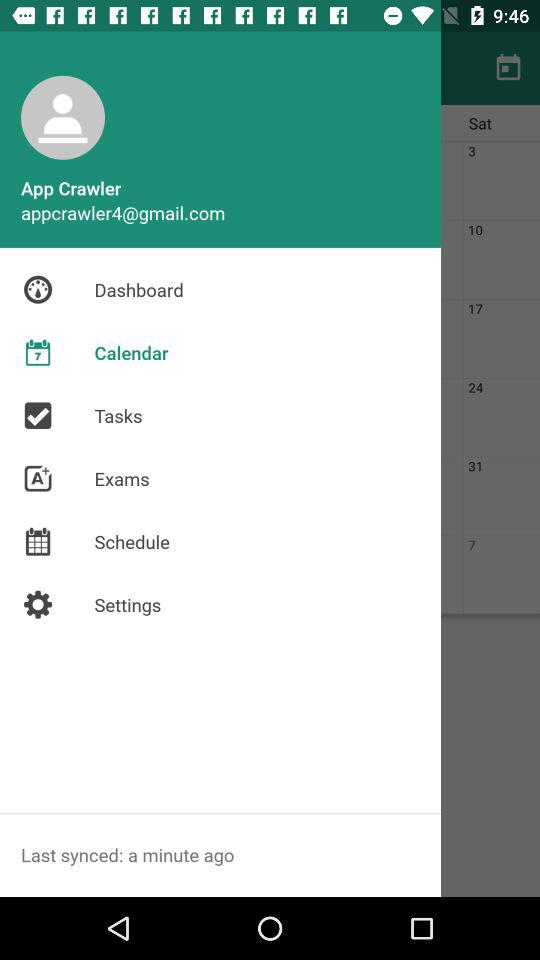When was the last sync done? The last sync was done a minute ago. 